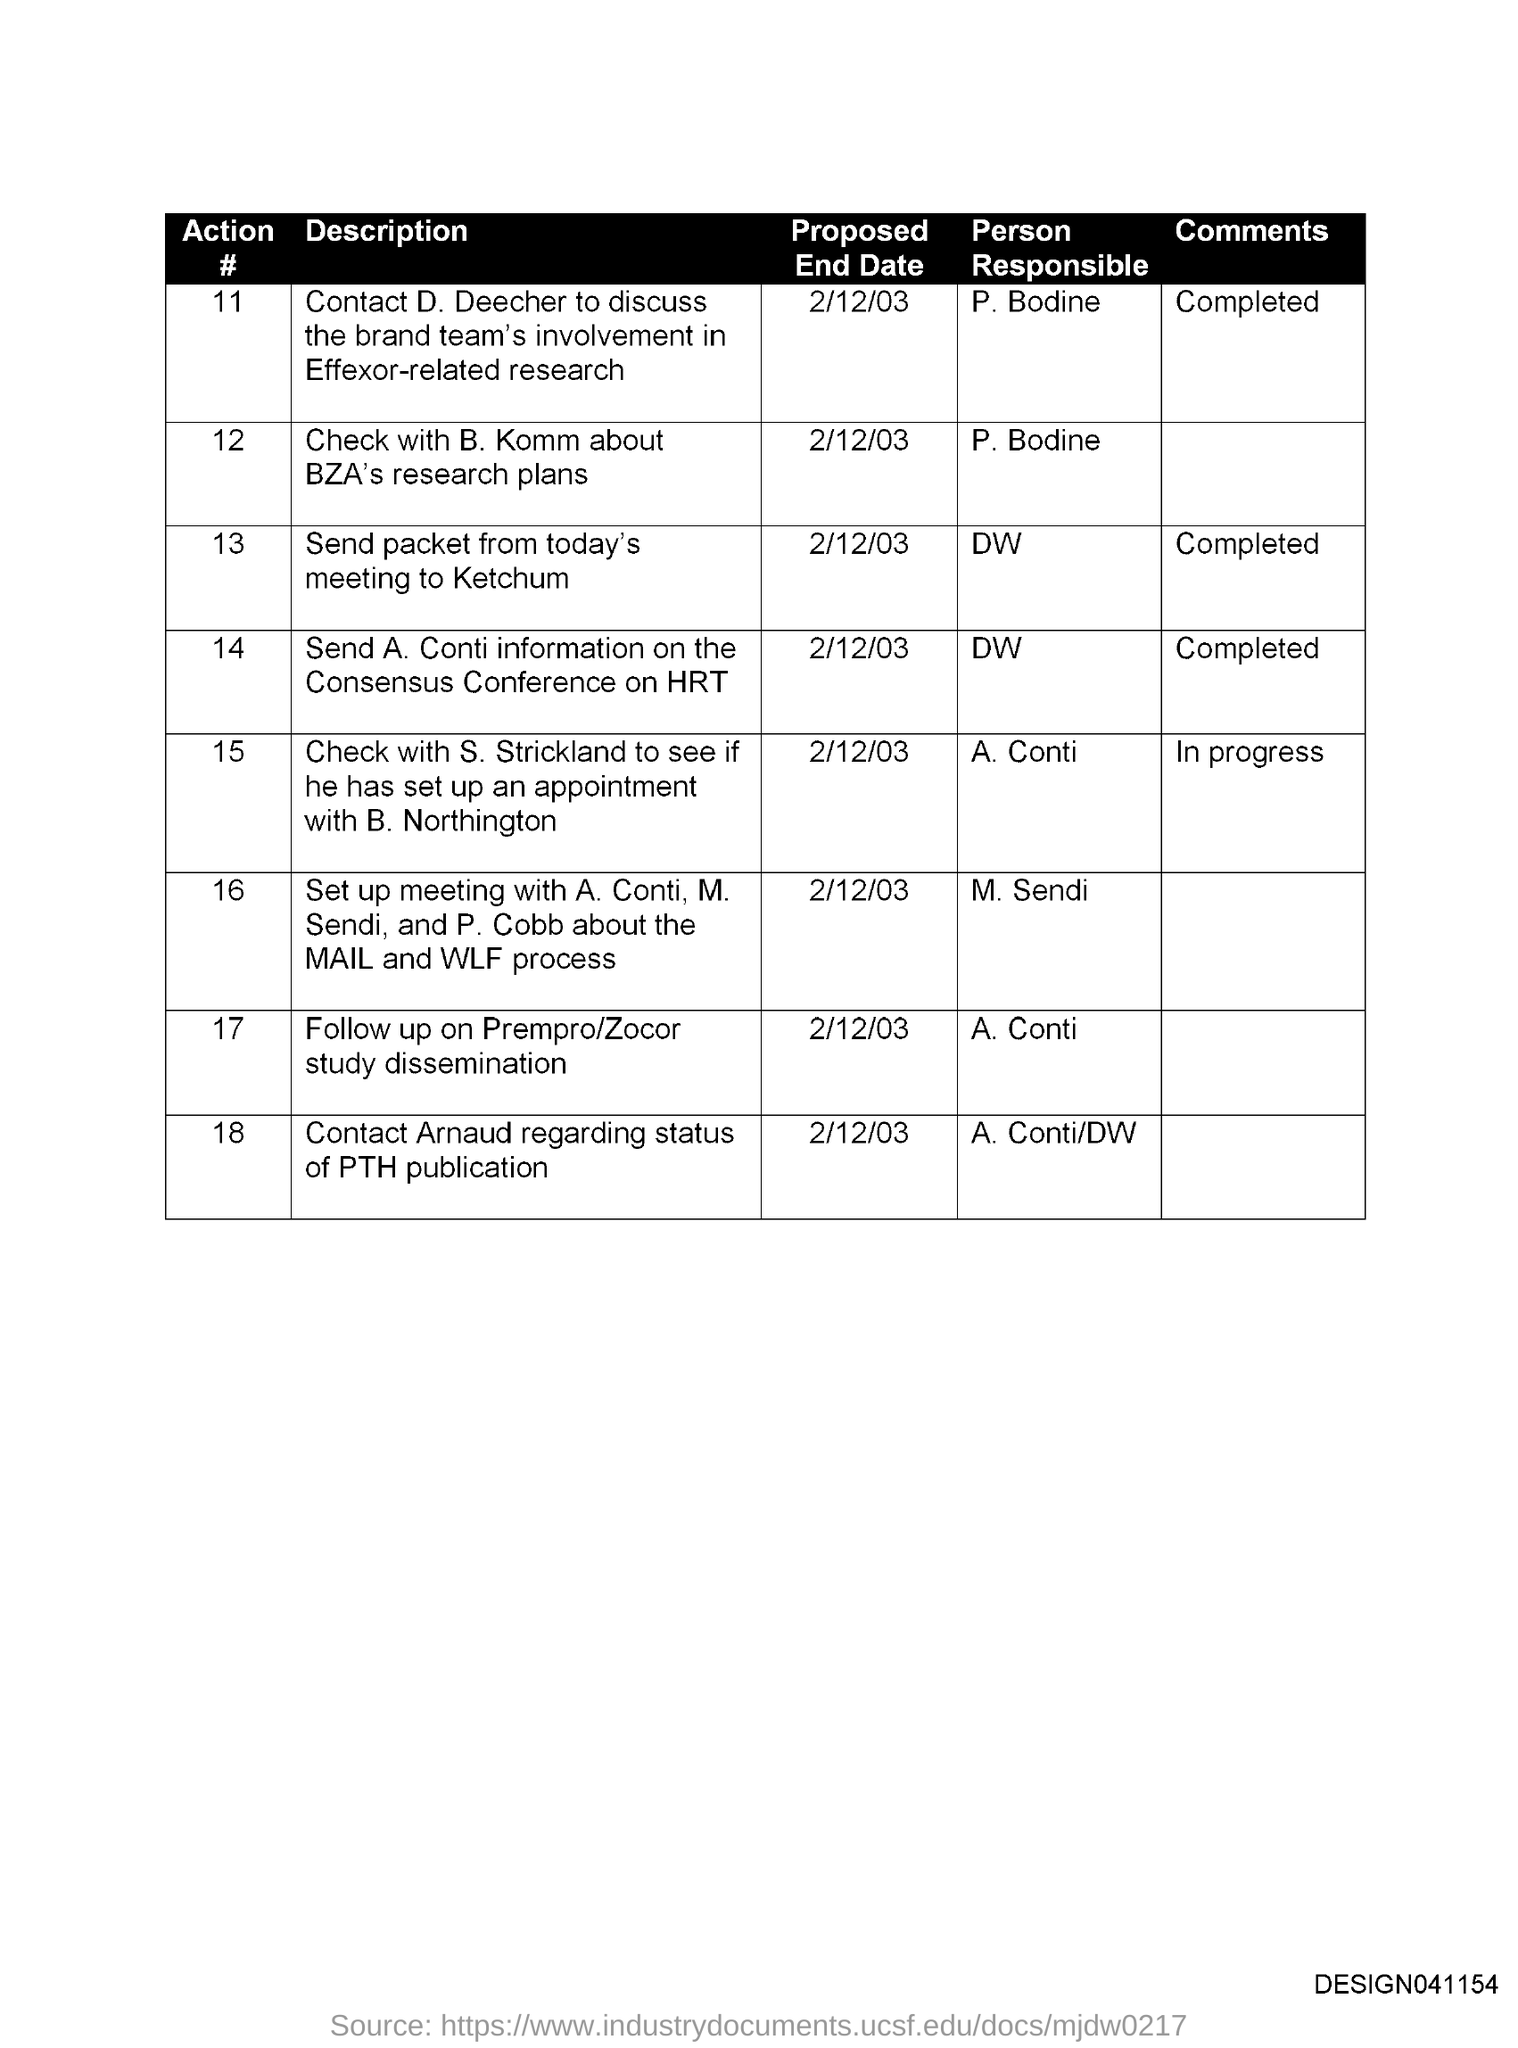Who is the person responsible to send packet from today's meeting to Ketchum?
Your answer should be compact. DW. What is the proposed end date to follow up on prempro/zocor study dissemination?
Ensure brevity in your answer.  2/12/03. Who is the person responsible to contact Arnaud regarding status of PTH publication?
Your answer should be very brief. A. Conti /DW. What is the proposed end date to check with B. Komm about BZA's research plans?
Offer a very short reply. 2/12/03. Who is the person responsible to check with B. Komm about BZA's research plans?
Keep it short and to the point. P. Bodine. 